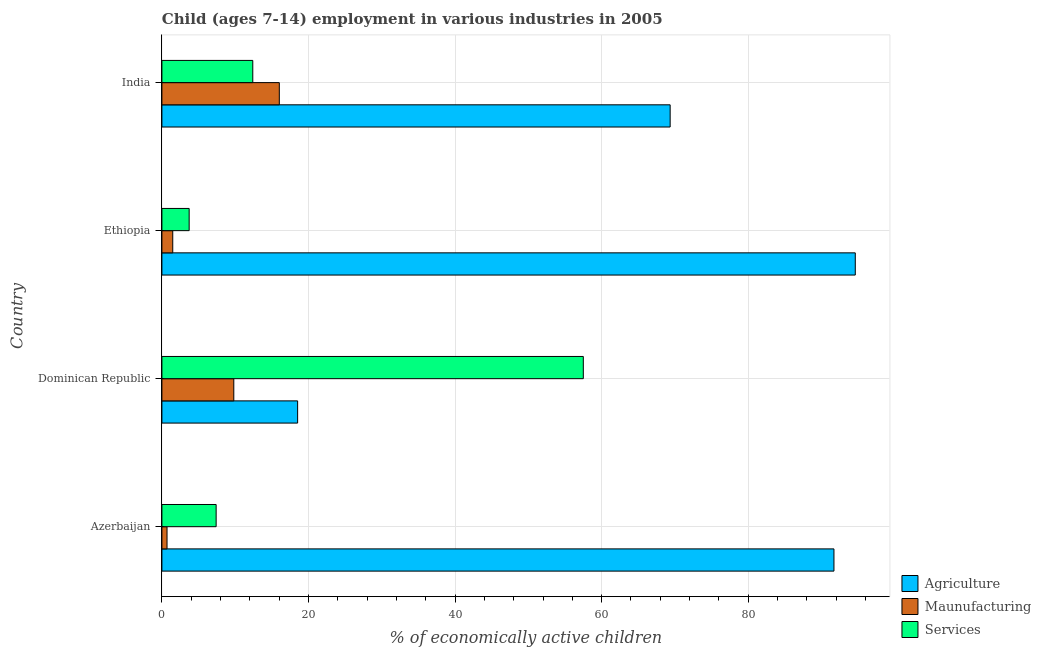Are the number of bars per tick equal to the number of legend labels?
Offer a terse response. Yes. Are the number of bars on each tick of the Y-axis equal?
Make the answer very short. Yes. What is the label of the 3rd group of bars from the top?
Give a very brief answer. Dominican Republic. In how many cases, is the number of bars for a given country not equal to the number of legend labels?
Your answer should be very brief. 0. What is the percentage of economically active children in agriculture in India?
Provide a succinct answer. 69.35. Across all countries, what is the maximum percentage of economically active children in services?
Your response must be concise. 57.5. Across all countries, what is the minimum percentage of economically active children in services?
Give a very brief answer. 3.72. In which country was the percentage of economically active children in agriculture maximum?
Give a very brief answer. Ethiopia. In which country was the percentage of economically active children in services minimum?
Make the answer very short. Ethiopia. What is the total percentage of economically active children in agriculture in the graph?
Provide a short and direct response. 274.18. What is the difference between the percentage of economically active children in manufacturing in Dominican Republic and that in India?
Ensure brevity in your answer.  -6.21. What is the difference between the percentage of economically active children in services in Dominican Republic and the percentage of economically active children in manufacturing in Ethiopia?
Your answer should be compact. 56.02. What is the average percentage of economically active children in manufacturing per country?
Offer a very short reply. 7. What is the difference between the percentage of economically active children in agriculture and percentage of economically active children in manufacturing in India?
Keep it short and to the point. 53.33. In how many countries, is the percentage of economically active children in services greater than 64 %?
Ensure brevity in your answer.  0. What is the ratio of the percentage of economically active children in services in Azerbaijan to that in India?
Make the answer very short. 0.6. Is the difference between the percentage of economically active children in agriculture in Ethiopia and India greater than the difference between the percentage of economically active children in manufacturing in Ethiopia and India?
Offer a terse response. Yes. What is the difference between the highest and the second highest percentage of economically active children in agriculture?
Keep it short and to the point. 2.91. What is the difference between the highest and the lowest percentage of economically active children in services?
Provide a succinct answer. 53.78. In how many countries, is the percentage of economically active children in agriculture greater than the average percentage of economically active children in agriculture taken over all countries?
Your response must be concise. 3. Is the sum of the percentage of economically active children in services in Azerbaijan and Ethiopia greater than the maximum percentage of economically active children in manufacturing across all countries?
Ensure brevity in your answer.  No. What does the 3rd bar from the top in Dominican Republic represents?
Provide a short and direct response. Agriculture. What does the 3rd bar from the bottom in Ethiopia represents?
Ensure brevity in your answer.  Services. Is it the case that in every country, the sum of the percentage of economically active children in agriculture and percentage of economically active children in manufacturing is greater than the percentage of economically active children in services?
Your response must be concise. No. Are all the bars in the graph horizontal?
Your answer should be very brief. Yes. How many countries are there in the graph?
Keep it short and to the point. 4. Are the values on the major ticks of X-axis written in scientific E-notation?
Keep it short and to the point. No. Does the graph contain any zero values?
Keep it short and to the point. No. Where does the legend appear in the graph?
Keep it short and to the point. Bottom right. How are the legend labels stacked?
Ensure brevity in your answer.  Vertical. What is the title of the graph?
Give a very brief answer. Child (ages 7-14) employment in various industries in 2005. What is the label or title of the X-axis?
Your answer should be compact. % of economically active children. What is the label or title of the Y-axis?
Offer a very short reply. Country. What is the % of economically active children in Agriculture in Azerbaijan?
Provide a short and direct response. 91.7. What is the % of economically active children of Services in Azerbaijan?
Give a very brief answer. 7.4. What is the % of economically active children in Agriculture in Dominican Republic?
Offer a very short reply. 18.52. What is the % of economically active children in Maunufacturing in Dominican Republic?
Your answer should be compact. 9.81. What is the % of economically active children of Services in Dominican Republic?
Provide a succinct answer. 57.5. What is the % of economically active children in Agriculture in Ethiopia?
Offer a very short reply. 94.61. What is the % of economically active children in Maunufacturing in Ethiopia?
Ensure brevity in your answer.  1.48. What is the % of economically active children of Services in Ethiopia?
Make the answer very short. 3.72. What is the % of economically active children in Agriculture in India?
Offer a terse response. 69.35. What is the % of economically active children in Maunufacturing in India?
Offer a very short reply. 16.02. Across all countries, what is the maximum % of economically active children in Agriculture?
Provide a short and direct response. 94.61. Across all countries, what is the maximum % of economically active children in Maunufacturing?
Offer a very short reply. 16.02. Across all countries, what is the maximum % of economically active children of Services?
Provide a succinct answer. 57.5. Across all countries, what is the minimum % of economically active children in Agriculture?
Your response must be concise. 18.52. Across all countries, what is the minimum % of economically active children in Maunufacturing?
Your response must be concise. 0.7. Across all countries, what is the minimum % of economically active children in Services?
Ensure brevity in your answer.  3.72. What is the total % of economically active children in Agriculture in the graph?
Provide a succinct answer. 274.18. What is the total % of economically active children in Maunufacturing in the graph?
Provide a short and direct response. 28.01. What is the total % of economically active children in Services in the graph?
Your answer should be very brief. 81.02. What is the difference between the % of economically active children of Agriculture in Azerbaijan and that in Dominican Republic?
Keep it short and to the point. 73.18. What is the difference between the % of economically active children in Maunufacturing in Azerbaijan and that in Dominican Republic?
Provide a succinct answer. -9.11. What is the difference between the % of economically active children in Services in Azerbaijan and that in Dominican Republic?
Your answer should be compact. -50.1. What is the difference between the % of economically active children in Agriculture in Azerbaijan and that in Ethiopia?
Your answer should be compact. -2.91. What is the difference between the % of economically active children of Maunufacturing in Azerbaijan and that in Ethiopia?
Make the answer very short. -0.78. What is the difference between the % of economically active children of Services in Azerbaijan and that in Ethiopia?
Ensure brevity in your answer.  3.68. What is the difference between the % of economically active children of Agriculture in Azerbaijan and that in India?
Keep it short and to the point. 22.35. What is the difference between the % of economically active children in Maunufacturing in Azerbaijan and that in India?
Your answer should be compact. -15.32. What is the difference between the % of economically active children of Agriculture in Dominican Republic and that in Ethiopia?
Ensure brevity in your answer.  -76.09. What is the difference between the % of economically active children in Maunufacturing in Dominican Republic and that in Ethiopia?
Provide a succinct answer. 8.33. What is the difference between the % of economically active children of Services in Dominican Republic and that in Ethiopia?
Offer a terse response. 53.78. What is the difference between the % of economically active children in Agriculture in Dominican Republic and that in India?
Your answer should be compact. -50.83. What is the difference between the % of economically active children of Maunufacturing in Dominican Republic and that in India?
Provide a short and direct response. -6.21. What is the difference between the % of economically active children in Services in Dominican Republic and that in India?
Your response must be concise. 45.1. What is the difference between the % of economically active children of Agriculture in Ethiopia and that in India?
Your response must be concise. 25.26. What is the difference between the % of economically active children of Maunufacturing in Ethiopia and that in India?
Provide a succinct answer. -14.54. What is the difference between the % of economically active children of Services in Ethiopia and that in India?
Make the answer very short. -8.68. What is the difference between the % of economically active children in Agriculture in Azerbaijan and the % of economically active children in Maunufacturing in Dominican Republic?
Provide a succinct answer. 81.89. What is the difference between the % of economically active children of Agriculture in Azerbaijan and the % of economically active children of Services in Dominican Republic?
Offer a very short reply. 34.2. What is the difference between the % of economically active children of Maunufacturing in Azerbaijan and the % of economically active children of Services in Dominican Republic?
Make the answer very short. -56.8. What is the difference between the % of economically active children of Agriculture in Azerbaijan and the % of economically active children of Maunufacturing in Ethiopia?
Ensure brevity in your answer.  90.22. What is the difference between the % of economically active children in Agriculture in Azerbaijan and the % of economically active children in Services in Ethiopia?
Keep it short and to the point. 87.98. What is the difference between the % of economically active children of Maunufacturing in Azerbaijan and the % of economically active children of Services in Ethiopia?
Keep it short and to the point. -3.02. What is the difference between the % of economically active children in Agriculture in Azerbaijan and the % of economically active children in Maunufacturing in India?
Provide a short and direct response. 75.68. What is the difference between the % of economically active children of Agriculture in Azerbaijan and the % of economically active children of Services in India?
Offer a terse response. 79.3. What is the difference between the % of economically active children of Agriculture in Dominican Republic and the % of economically active children of Maunufacturing in Ethiopia?
Offer a terse response. 17.04. What is the difference between the % of economically active children in Maunufacturing in Dominican Republic and the % of economically active children in Services in Ethiopia?
Offer a terse response. 6.09. What is the difference between the % of economically active children in Agriculture in Dominican Republic and the % of economically active children in Maunufacturing in India?
Your answer should be compact. 2.5. What is the difference between the % of economically active children of Agriculture in Dominican Republic and the % of economically active children of Services in India?
Make the answer very short. 6.12. What is the difference between the % of economically active children in Maunufacturing in Dominican Republic and the % of economically active children in Services in India?
Ensure brevity in your answer.  -2.59. What is the difference between the % of economically active children in Agriculture in Ethiopia and the % of economically active children in Maunufacturing in India?
Your answer should be compact. 78.59. What is the difference between the % of economically active children of Agriculture in Ethiopia and the % of economically active children of Services in India?
Give a very brief answer. 82.21. What is the difference between the % of economically active children in Maunufacturing in Ethiopia and the % of economically active children in Services in India?
Provide a short and direct response. -10.92. What is the average % of economically active children in Agriculture per country?
Offer a very short reply. 68.55. What is the average % of economically active children in Maunufacturing per country?
Your answer should be compact. 7. What is the average % of economically active children of Services per country?
Your answer should be very brief. 20.25. What is the difference between the % of economically active children in Agriculture and % of economically active children in Maunufacturing in Azerbaijan?
Make the answer very short. 91. What is the difference between the % of economically active children in Agriculture and % of economically active children in Services in Azerbaijan?
Make the answer very short. 84.3. What is the difference between the % of economically active children of Maunufacturing and % of economically active children of Services in Azerbaijan?
Offer a very short reply. -6.7. What is the difference between the % of economically active children of Agriculture and % of economically active children of Maunufacturing in Dominican Republic?
Ensure brevity in your answer.  8.71. What is the difference between the % of economically active children in Agriculture and % of economically active children in Services in Dominican Republic?
Ensure brevity in your answer.  -38.98. What is the difference between the % of economically active children of Maunufacturing and % of economically active children of Services in Dominican Republic?
Keep it short and to the point. -47.69. What is the difference between the % of economically active children in Agriculture and % of economically active children in Maunufacturing in Ethiopia?
Give a very brief answer. 93.13. What is the difference between the % of economically active children of Agriculture and % of economically active children of Services in Ethiopia?
Give a very brief answer. 90.89. What is the difference between the % of economically active children in Maunufacturing and % of economically active children in Services in Ethiopia?
Your answer should be compact. -2.24. What is the difference between the % of economically active children in Agriculture and % of economically active children in Maunufacturing in India?
Offer a very short reply. 53.33. What is the difference between the % of economically active children in Agriculture and % of economically active children in Services in India?
Provide a succinct answer. 56.95. What is the difference between the % of economically active children in Maunufacturing and % of economically active children in Services in India?
Your answer should be very brief. 3.62. What is the ratio of the % of economically active children in Agriculture in Azerbaijan to that in Dominican Republic?
Give a very brief answer. 4.95. What is the ratio of the % of economically active children of Maunufacturing in Azerbaijan to that in Dominican Republic?
Provide a short and direct response. 0.07. What is the ratio of the % of economically active children of Services in Azerbaijan to that in Dominican Republic?
Ensure brevity in your answer.  0.13. What is the ratio of the % of economically active children of Agriculture in Azerbaijan to that in Ethiopia?
Your response must be concise. 0.97. What is the ratio of the % of economically active children in Maunufacturing in Azerbaijan to that in Ethiopia?
Your answer should be very brief. 0.47. What is the ratio of the % of economically active children of Services in Azerbaijan to that in Ethiopia?
Keep it short and to the point. 1.99. What is the ratio of the % of economically active children in Agriculture in Azerbaijan to that in India?
Provide a short and direct response. 1.32. What is the ratio of the % of economically active children in Maunufacturing in Azerbaijan to that in India?
Provide a short and direct response. 0.04. What is the ratio of the % of economically active children in Services in Azerbaijan to that in India?
Keep it short and to the point. 0.6. What is the ratio of the % of economically active children of Agriculture in Dominican Republic to that in Ethiopia?
Keep it short and to the point. 0.2. What is the ratio of the % of economically active children in Maunufacturing in Dominican Republic to that in Ethiopia?
Ensure brevity in your answer.  6.63. What is the ratio of the % of economically active children in Services in Dominican Republic to that in Ethiopia?
Make the answer very short. 15.46. What is the ratio of the % of economically active children of Agriculture in Dominican Republic to that in India?
Your answer should be very brief. 0.27. What is the ratio of the % of economically active children in Maunufacturing in Dominican Republic to that in India?
Your response must be concise. 0.61. What is the ratio of the % of economically active children of Services in Dominican Republic to that in India?
Give a very brief answer. 4.64. What is the ratio of the % of economically active children in Agriculture in Ethiopia to that in India?
Provide a succinct answer. 1.36. What is the ratio of the % of economically active children in Maunufacturing in Ethiopia to that in India?
Offer a terse response. 0.09. What is the ratio of the % of economically active children in Services in Ethiopia to that in India?
Your answer should be very brief. 0.3. What is the difference between the highest and the second highest % of economically active children in Agriculture?
Your answer should be compact. 2.91. What is the difference between the highest and the second highest % of economically active children of Maunufacturing?
Make the answer very short. 6.21. What is the difference between the highest and the second highest % of economically active children in Services?
Keep it short and to the point. 45.1. What is the difference between the highest and the lowest % of economically active children of Agriculture?
Your response must be concise. 76.09. What is the difference between the highest and the lowest % of economically active children of Maunufacturing?
Your answer should be compact. 15.32. What is the difference between the highest and the lowest % of economically active children of Services?
Offer a very short reply. 53.78. 